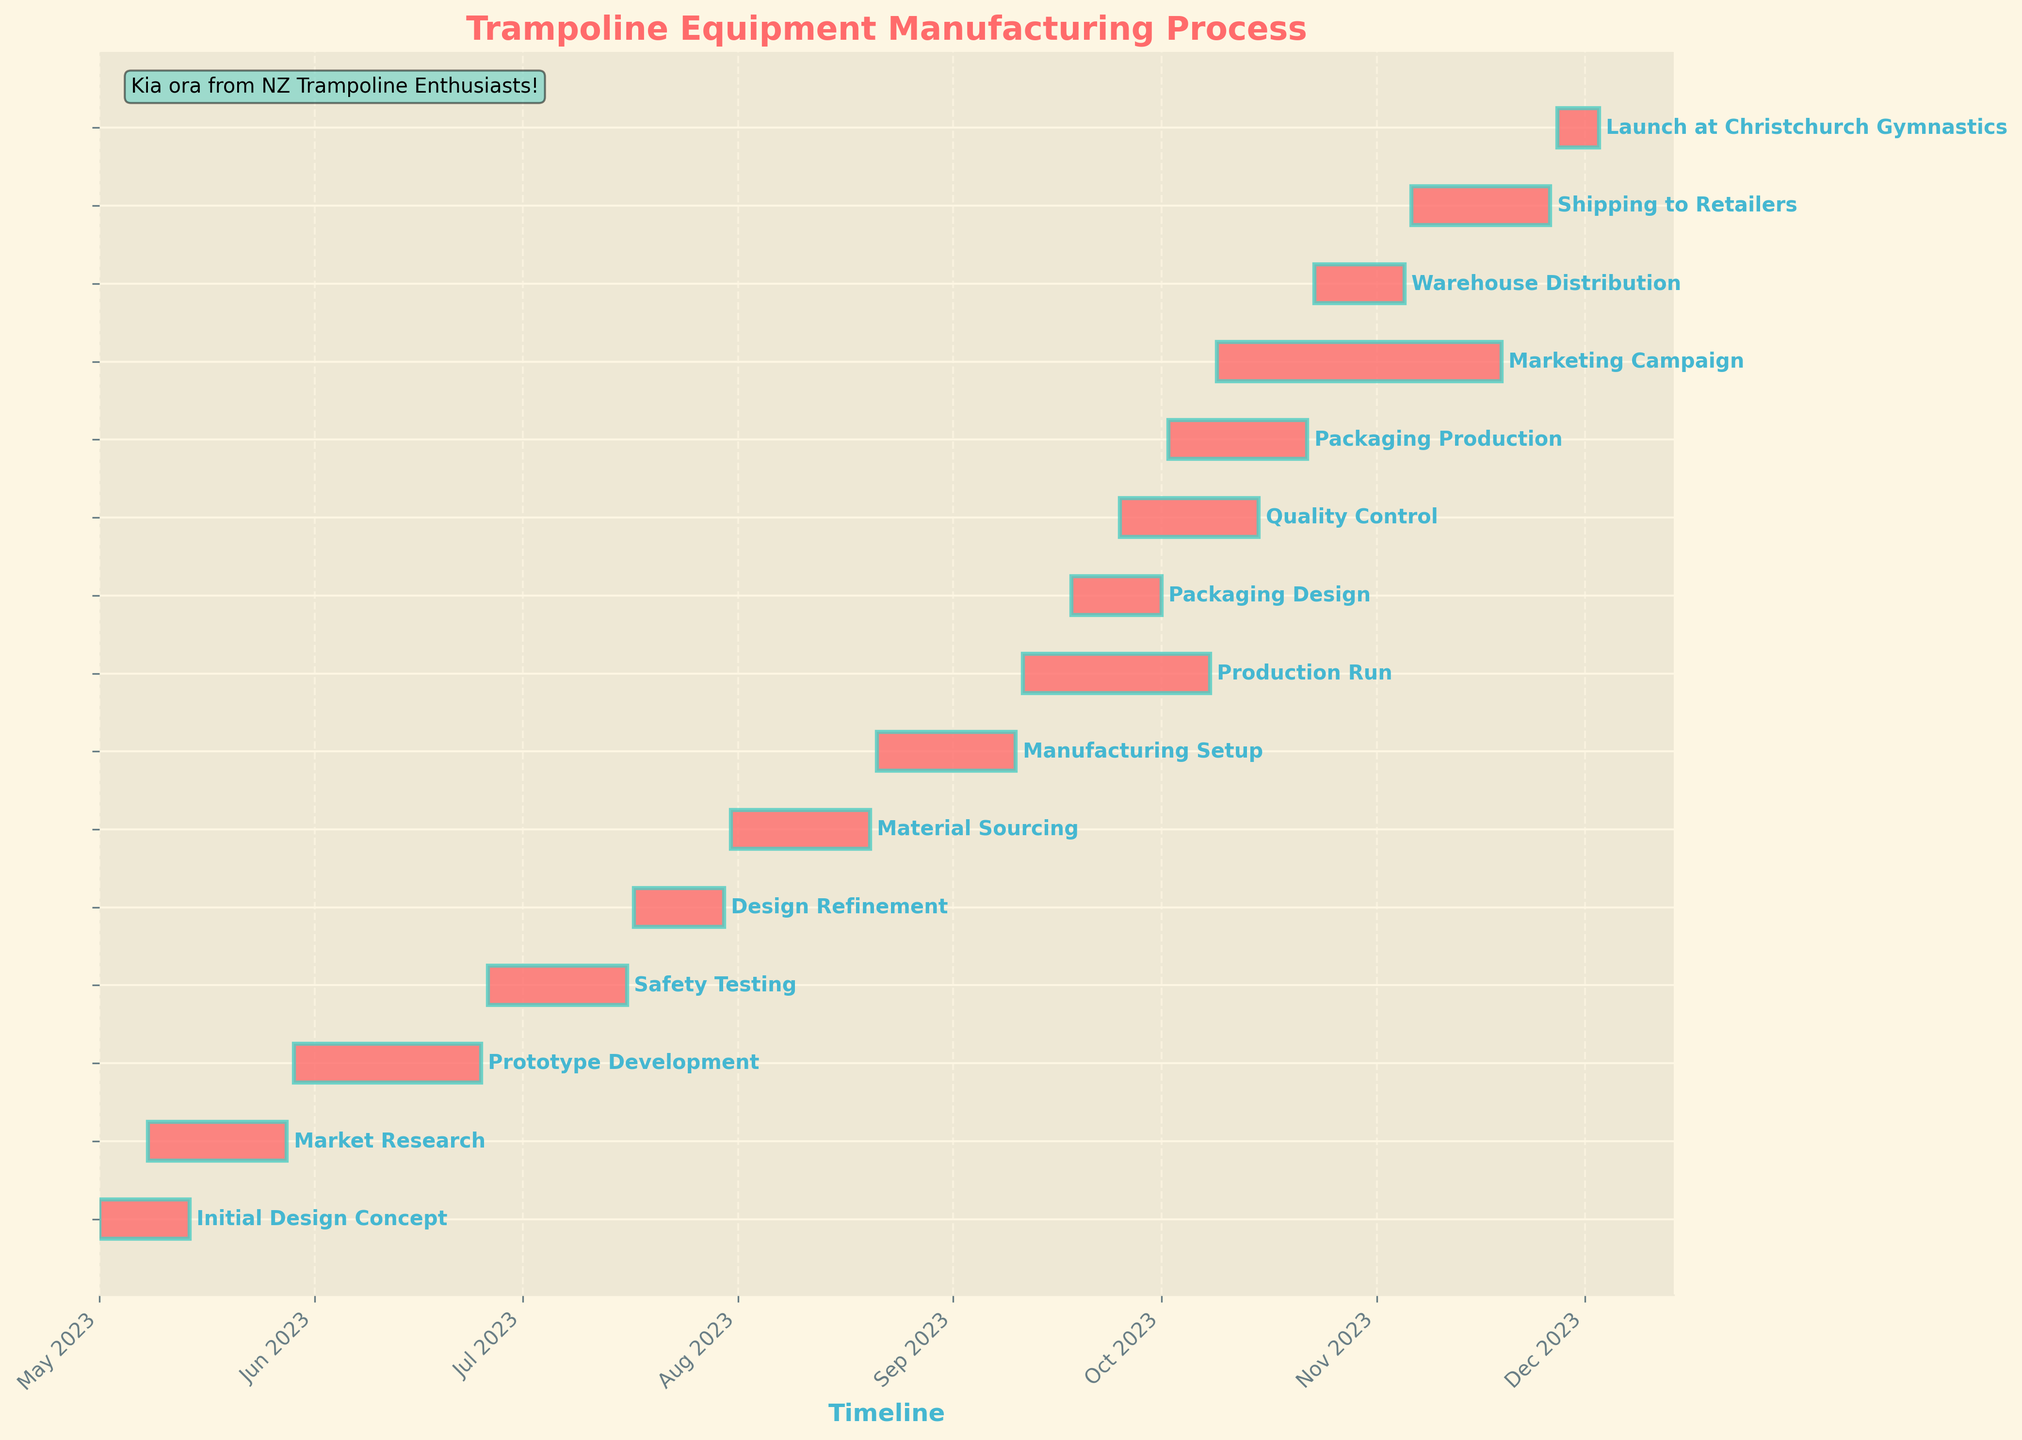What is the title of the Gantt chart? The title is usually displayed at the top of the chart for quick understanding of the chart's subject.
Answer: Trampoline Equipment Manufacturing Process What task has the longest duration? The task with the longest duration is identified by finding the bar that spans the longest time period from start to end.
Answer: Marketing Campaign When does the Prototype Development phase start and end? Locate the "Prototype Development" bar on the chart and note the start and end dates at the left and right ends of the bar.
Answer: May 29, 2023 to June 25, 2023 Which tasks are scheduled to start in September? Review the start dates of all tasks and find those that start within the month of September.
Answer: Production Run, Quality Control, Packaging Design When does the Safety Testing phase end? Locate the "Safety Testing" bar on the chart and note the end date at the right end of the bar.
Answer: July 16, 2023 Which task(s) overlap with the initial part of the Manufacturing Setup phase? Identify the start and end dates of the Manufacturing Setup phase and compare with other tasks that have overlapping date ranges.
Answer: Material Sourcing What is the total duration of the Production Run and the Packaging Production combined? Calculate the duration of each task separately and sum them up. Production Run: 28 days (Sep 11 to Oct 8); Packaging Production: 20 days (Oct 2 to Oct 22). 28 + 20 = 48 days
Answer: 48 days Which task directly follows the Design Refinement phase? Find the end date of the Design Refinement phase and identify the immediate next task with a start date.
Answer: Material Sourcing When is the earliest a trampoline could be available for shipping to retailers? Identify the end date of the Warehouse Distribution phase, which is the completion of the in-house process before shipping.
Answer: November 5, 2023 How many tasks are scheduled to occur simultaneously at any point in June? Review all tasks and their timelines to count how many overlap during June. Market Research, Prototype Development, Safety Testing, and overlaps from Initial Design Concept.
Answer: 3 tasks 